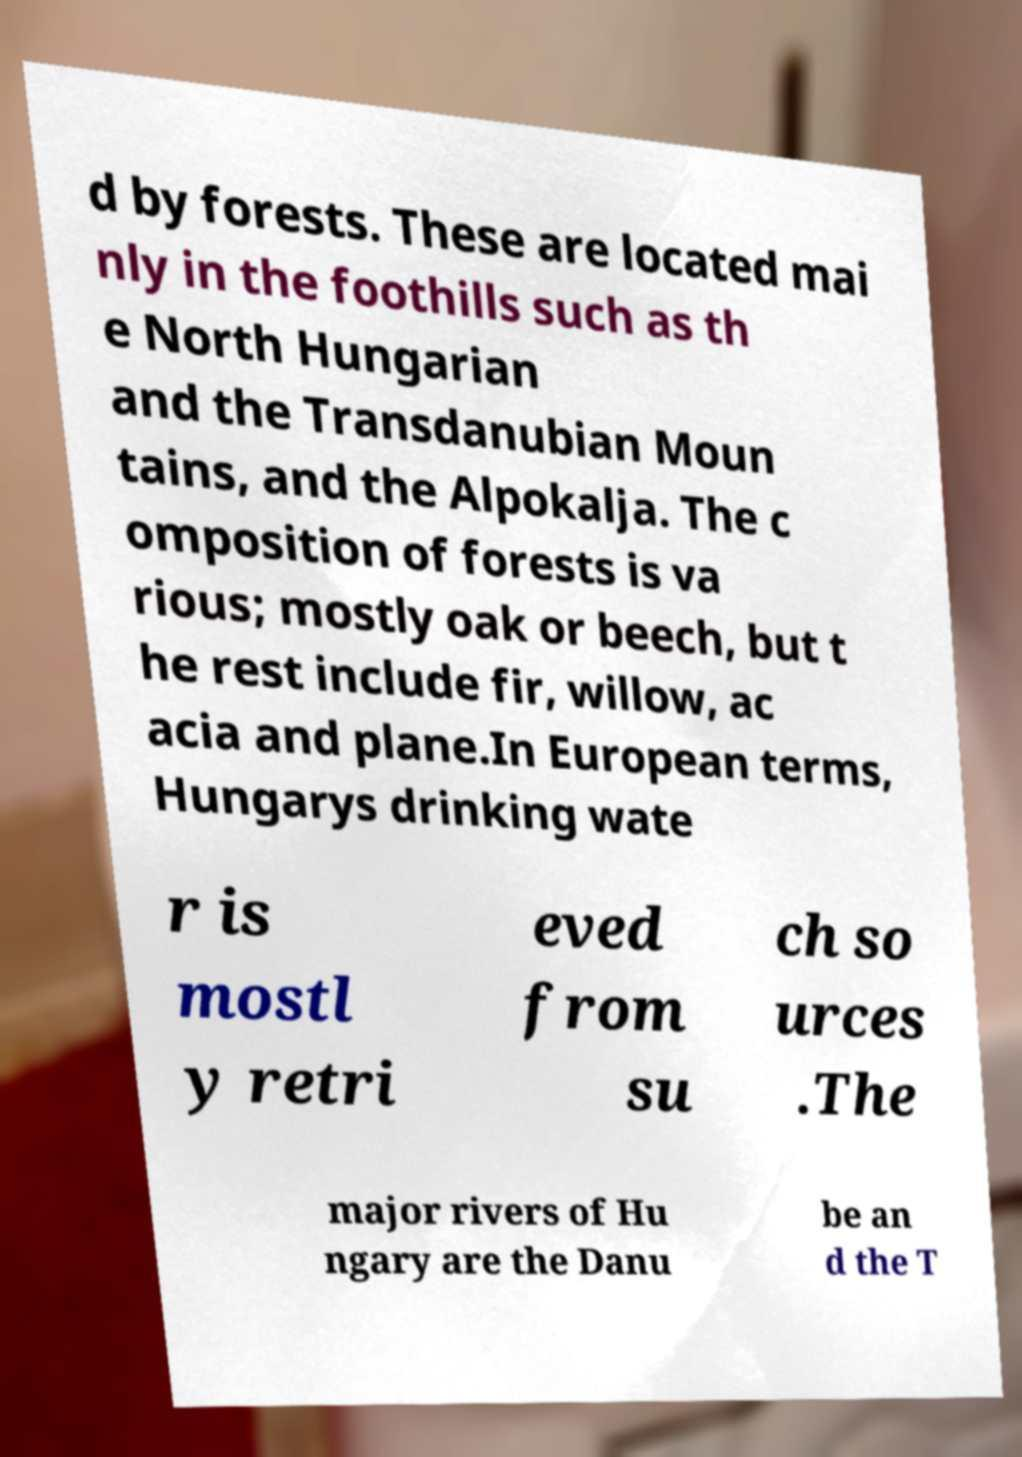I need the written content from this picture converted into text. Can you do that? d by forests. These are located mai nly in the foothills such as th e North Hungarian and the Transdanubian Moun tains, and the Alpokalja. The c omposition of forests is va rious; mostly oak or beech, but t he rest include fir, willow, ac acia and plane.In European terms, Hungarys drinking wate r is mostl y retri eved from su ch so urces .The major rivers of Hu ngary are the Danu be an d the T 